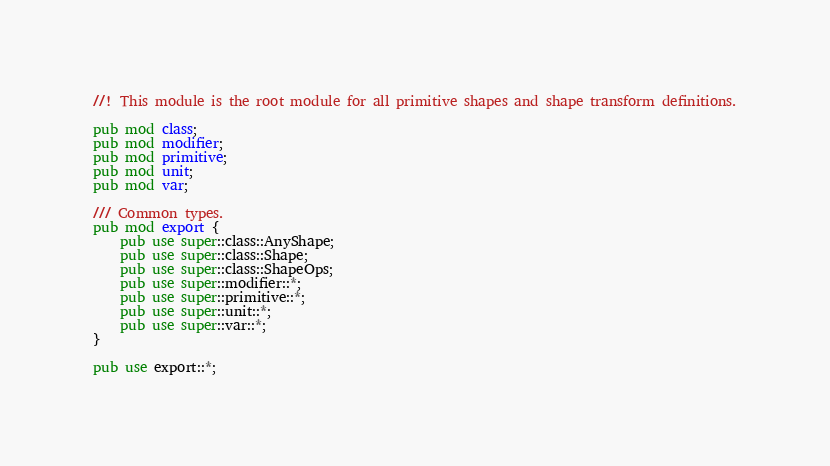Convert code to text. <code><loc_0><loc_0><loc_500><loc_500><_Rust_>//! This module is the root module for all primitive shapes and shape transform definitions.

pub mod class;
pub mod modifier;
pub mod primitive;
pub mod unit;
pub mod var;

/// Common types.
pub mod export {
    pub use super::class::AnyShape;
    pub use super::class::Shape;
    pub use super::class::ShapeOps;
    pub use super::modifier::*;
    pub use super::primitive::*;
    pub use super::unit::*;
    pub use super::var::*;
}

pub use export::*;
</code> 